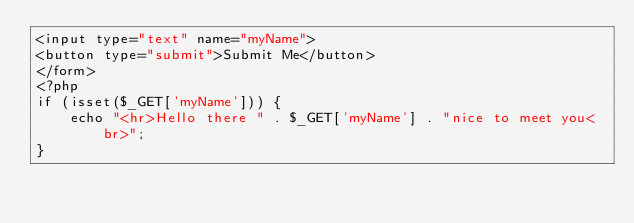<code> <loc_0><loc_0><loc_500><loc_500><_PHP_><input type="text" name="myName">
<button type="submit">Submit Me</button>
</form>
<?php
if (isset($_GET['myName'])) {
    echo "<hr>Hello there " . $_GET['myName'] . "nice to meet you<br>";
}</code> 